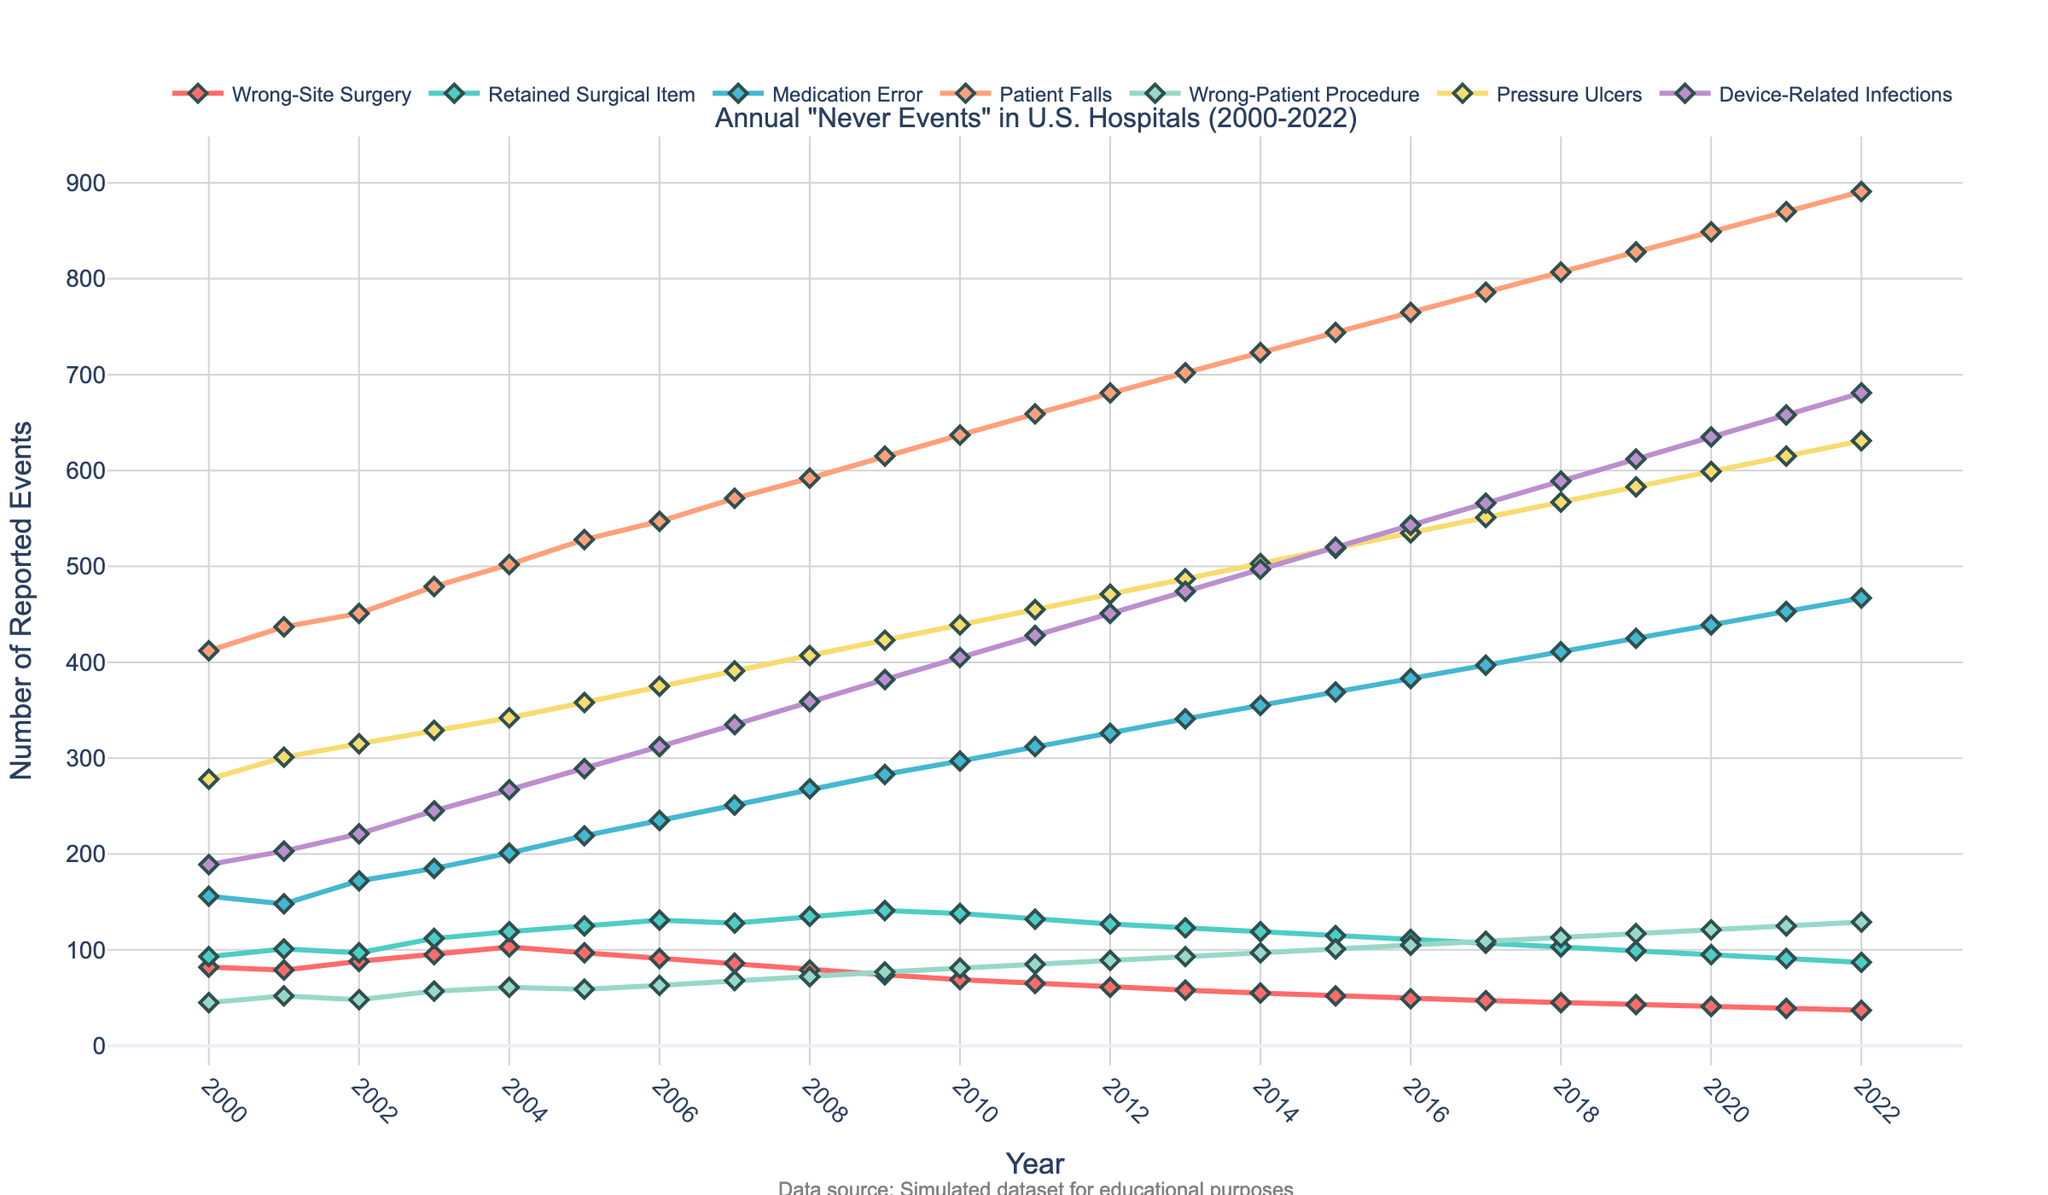What is the overall trend in the number of retained surgical items from 2000 to 2022? Examine the line for retained surgical items and observe whether the number increases, decreases, or remains constant over time. The line shows a gradual increase.
Answer: Gradual Increase Which year had the highest number of patient falls reported? Look at the line representing patient falls and identify the peak point. The peak occurs in 2022.
Answer: 2022 Between wrong-site surgery and wrong-patient procedures, which event type showed a more significant decrease from 2000 to 2022? Compare the start and end points for both event types by looking at their respective lines. Wrong-site surgery decreased from 82 to 37, while wrong-patient procedures decreased from 45 to 129. The decrease in wrong-site surgery is more significant.
Answer: Wrong-site surgery What is the difference in the number of medication errors between 2005 and 2015? Look at the data points for medication errors in 2005 and 2015, subtract the 2005 value from the 2015 value. In 2005, it was 219, and in 2015, it was 369, so the difference is 369 - 219 = 150.
Answer: 150 How much did the number of pressure ulcers increase from 2000 to 2022? Subtract the number of pressure ulcers in 2000 from the number in 2022. In 2000, the number was 278, and in 2022, it was 631, so the increase is 631 - 278 = 353.
Answer: 353 Which "never event" type consistently had the lowest number reported from 2000 to 2022? Compare the lines representing all event types and identify the one that remains lowest throughout the years. Wrong-patient procedures consistently have the lowest numbers.
Answer: Wrong-patient procedures What are the average annual reported cases for device-related infections from 2000 to 2022? Sum the numbers of device-related infections from each year and divide by the number of years (23 years). The total is 8981, so the average is 8981 / 23 ≈ 390.
Answer: Approximately 390 Which event type had the steepest increase in the number of cases from 2010 to 2022? Examine the slopes of the lines between these years for each event type. Patient falls have the steepest upward slope in this period.
Answer: Patient falls How did the number of wrong-site surgeries change from 2000 to 2022? Compare the number of wrong-site surgeries in 2000 and 2022. In 2000, there were 82 cases and in 2022, there were 37, indicating a decrease.
Answer: Decrease Compare the trends of medication errors and patient falls from 2000 to 2022. Observe the lines for medication errors and patient falls. Medication errors show a consistent increase, while patient falls also show an increasing trend but at a steeper rate.
Answer: Both increased, with patient falls increasing more steeply 